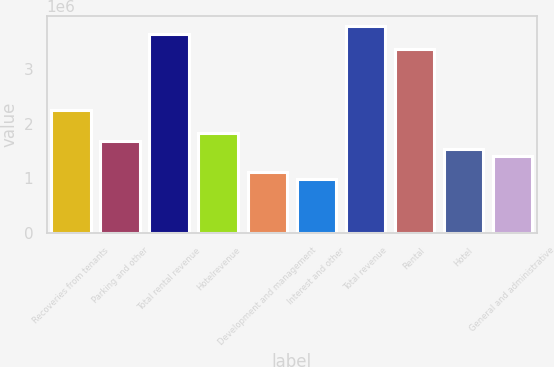Convert chart. <chart><loc_0><loc_0><loc_500><loc_500><bar_chart><fcel>Recoveries from tenants<fcel>Parking and other<fcel>Total rental revenue<fcel>Hotelrevenue<fcel>Development and management<fcel>Interest and other<fcel>Total revenue<fcel>Rental<fcel>Hotel<fcel>General and administrative<nl><fcel>2.24074e+06<fcel>1.68056e+06<fcel>3.64121e+06<fcel>1.8206e+06<fcel>1.12037e+06<fcel>980326<fcel>3.78125e+06<fcel>3.36112e+06<fcel>1.54051e+06<fcel>1.40046e+06<nl></chart> 